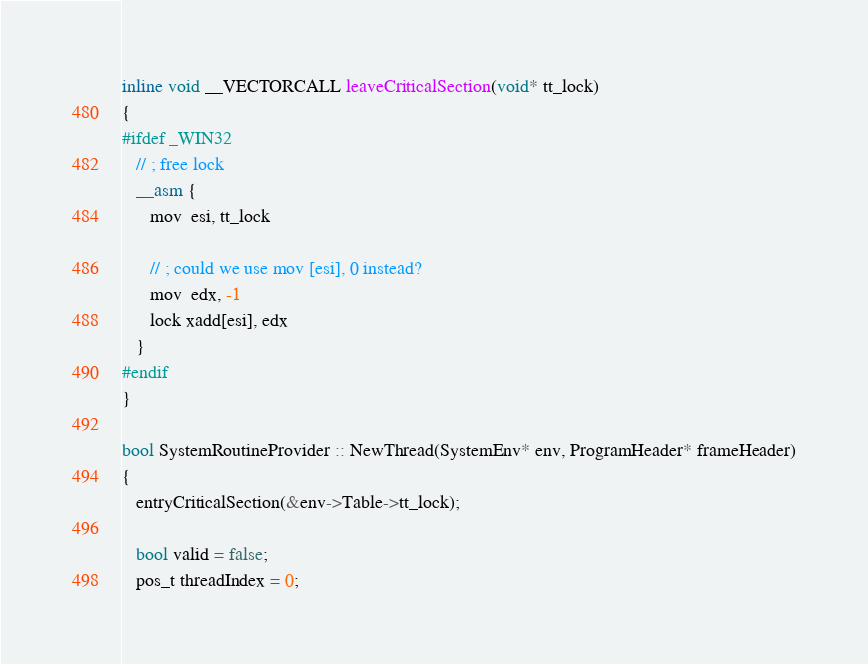Convert code to text. <code><loc_0><loc_0><loc_500><loc_500><_C++_>
inline void __VECTORCALL leaveCriticalSection(void* tt_lock)
{
#ifdef _WIN32
   // ; free lock
   __asm {
      mov  esi, tt_lock

      // ; could we use mov [esi], 0 instead?
      mov  edx, -1
      lock xadd[esi], edx
   }
#endif
}

bool SystemRoutineProvider :: NewThread(SystemEnv* env, ProgramHeader* frameHeader)
{
   entryCriticalSection(&env->Table->tt_lock);

   bool valid = false;
   pos_t threadIndex = 0;</code> 